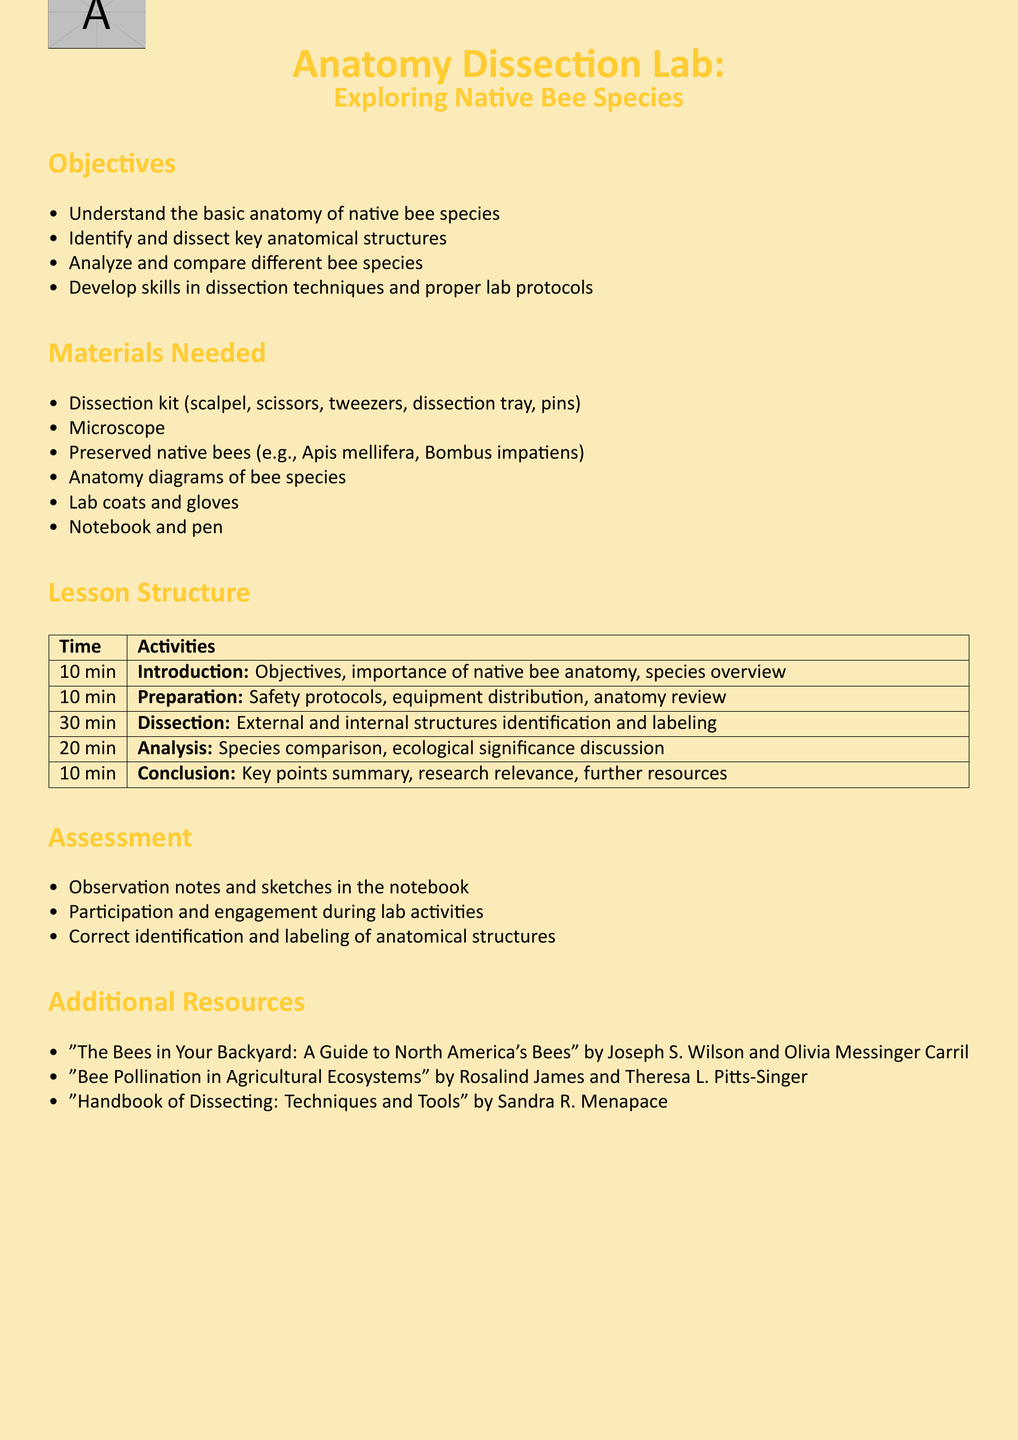What is the main focus of the lesson plan? The main focus of the lesson plan is on the anatomy dissection of native bee species.
Answer: Anatomy Dissection Lab: Exploring Native Bee Species How long is the dissection activity scheduled to last? The dissection activity is scheduled for 30 minutes as listed in the lesson structure.
Answer: 30 min What type of microscope is needed for the lab? The lab requires a standard microscope as per the materials needed section.
Answer: Microscope Which two bee species are mentioned for dissection? The document specifies preserved native bees including Apis mellifera and Bombus impatiens.
Answer: Apis mellifera, Bombus impatiens What skill is emphasized for development during the lesson? The lesson emphasizes the development of skills in dissection techniques.
Answer: Dissection techniques What is the time allocated for the conclusion section? The conclusion section is allocated 10 minutes according to the lesson structure.
Answer: 10 min Name one of the additional resources provided. One of the additional resources suggested is a book written by Joseph S. Wilson and Olivia Messinger Carril.
Answer: "The Bees in Your Backyard: A Guide to North America's Bees" What is the first objective of the lesson? The first objective of the lesson is to understand the basic anatomy of native bee species.
Answer: Understand the basic anatomy of native bee species 